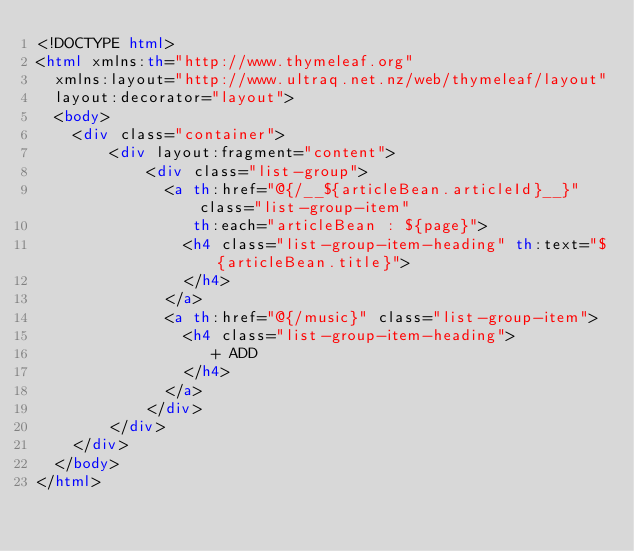Convert code to text. <code><loc_0><loc_0><loc_500><loc_500><_HTML_><!DOCTYPE html>
<html xmlns:th="http://www.thymeleaf.org"
  xmlns:layout="http://www.ultraq.net.nz/web/thymeleaf/layout"
  layout:decorator="layout">
  <body>
    <div class="container">
        <div layout:fragment="content">
            <div class="list-group">
              <a th:href="@{/__${articleBean.articleId}__}" class="list-group-item" 
                 th:each="articleBean : ${page}">
                <h4 class="list-group-item-heading" th:text="${articleBean.title}">
                </h4>
              </a>
              <a th:href="@{/music}" class="list-group-item">
                <h4 class="list-group-item-heading">
                   + ADD
                </h4>
              </a>
            </div>
        </div>
    </div>
  </body>
</html></code> 